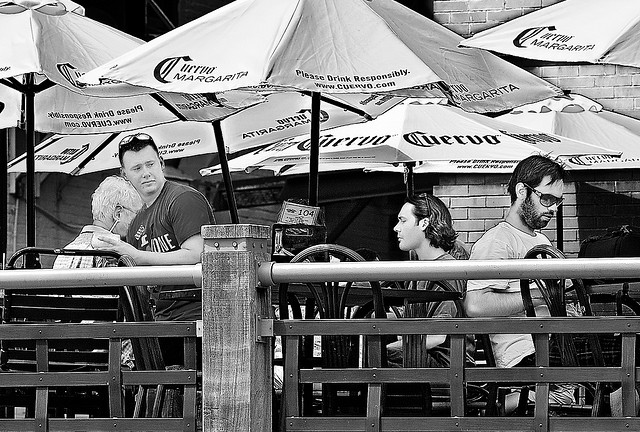Read and extract the text from this image. Please Drink MARGARITA Responsibly www.CUERVO.com MARGARITA MARGARIT C ONE 104 MARGARITA Cuervo C urrvo www.CUERVO.com Anho 